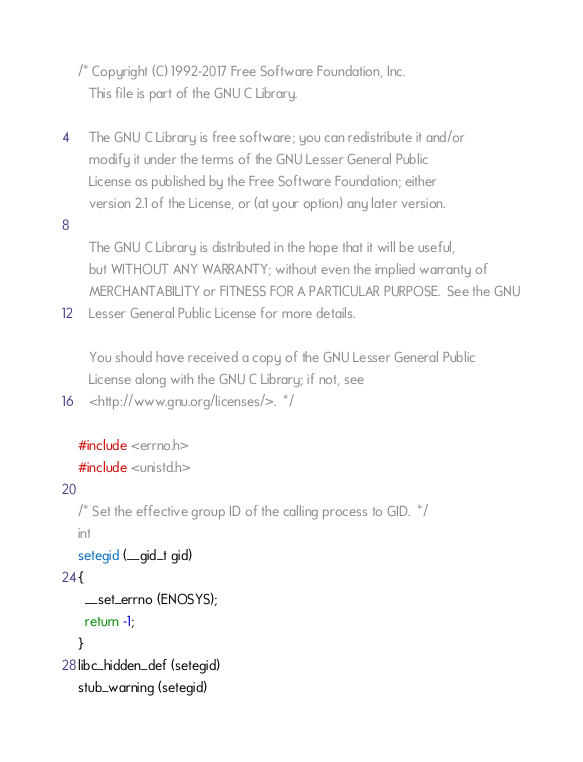<code> <loc_0><loc_0><loc_500><loc_500><_C_>/* Copyright (C) 1992-2017 Free Software Foundation, Inc.
   This file is part of the GNU C Library.

   The GNU C Library is free software; you can redistribute it and/or
   modify it under the terms of the GNU Lesser General Public
   License as published by the Free Software Foundation; either
   version 2.1 of the License, or (at your option) any later version.

   The GNU C Library is distributed in the hope that it will be useful,
   but WITHOUT ANY WARRANTY; without even the implied warranty of
   MERCHANTABILITY or FITNESS FOR A PARTICULAR PURPOSE.  See the GNU
   Lesser General Public License for more details.

   You should have received a copy of the GNU Lesser General Public
   License along with the GNU C Library; if not, see
   <http://www.gnu.org/licenses/>.  */

#include <errno.h>
#include <unistd.h>

/* Set the effective group ID of the calling process to GID.  */
int
setegid (__gid_t gid)
{
  __set_errno (ENOSYS);
  return -1;
}
libc_hidden_def (setegid)
stub_warning (setegid)
</code> 